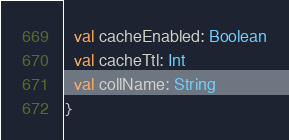Convert code to text. <code><loc_0><loc_0><loc_500><loc_500><_Scala_>  val cacheEnabled: Boolean
  val cacheTtl: Int
  val collName: String
}

</code> 